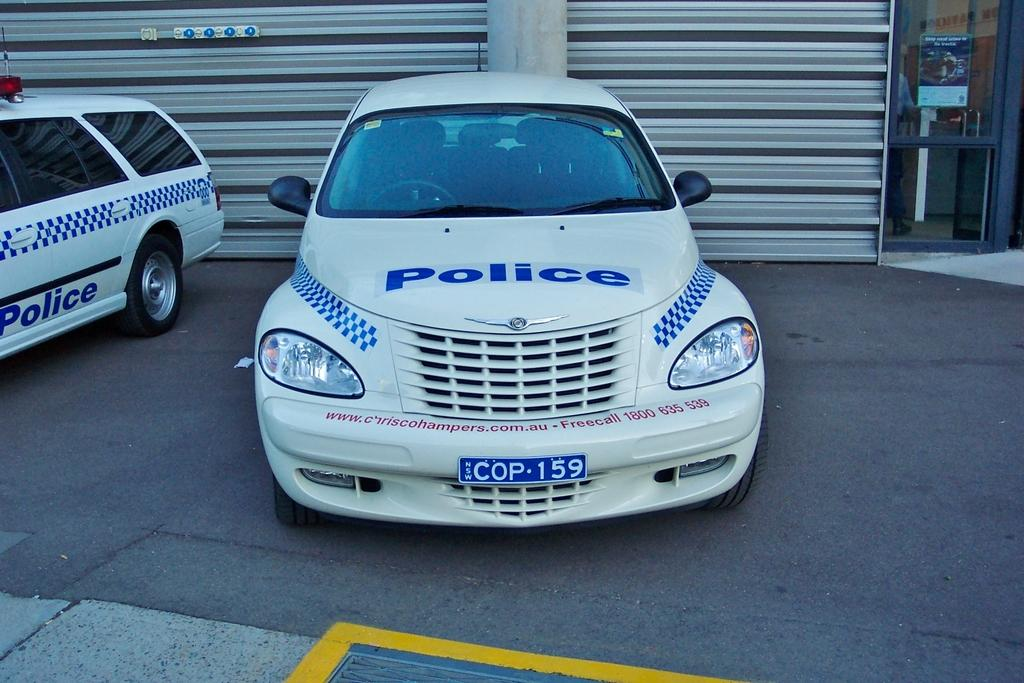<image>
Summarize the visual content of the image. The vehicle is used in Australia by local police and officers. 